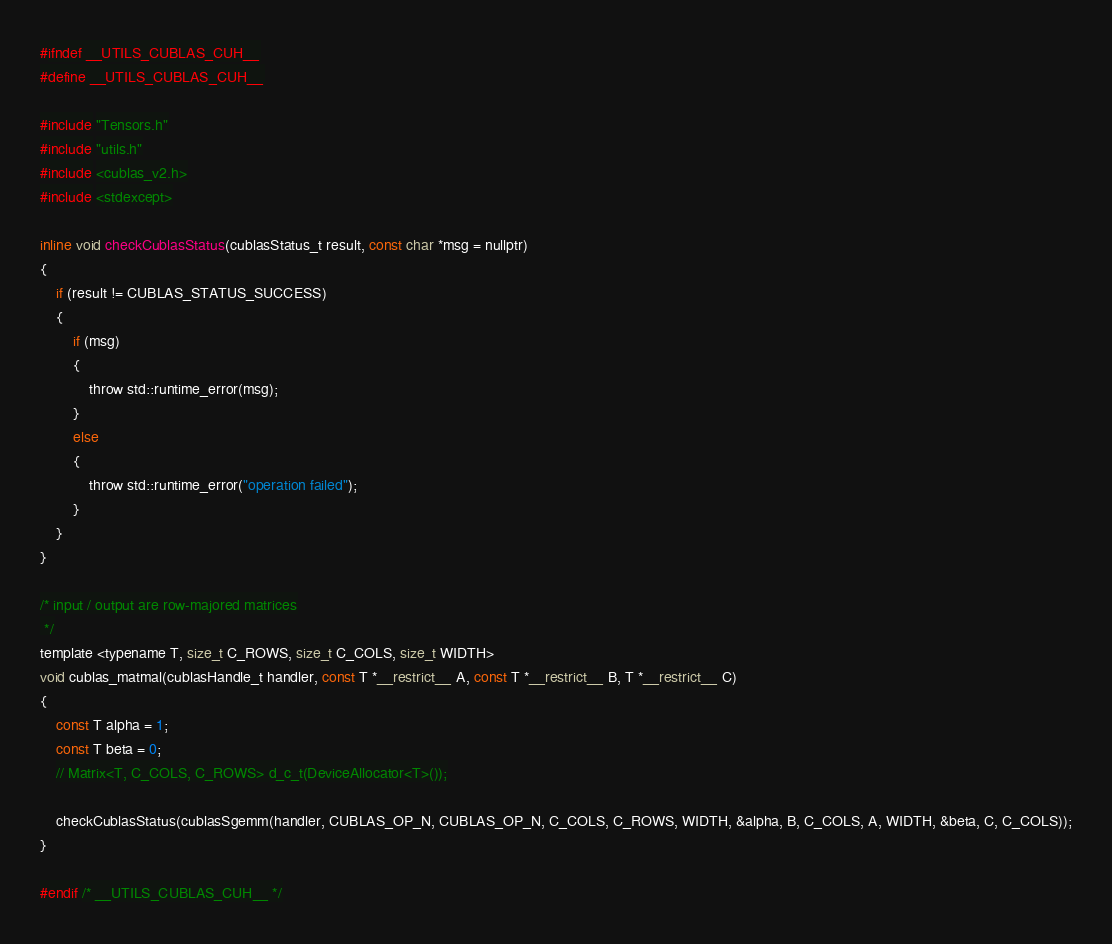<code> <loc_0><loc_0><loc_500><loc_500><_Cuda_>#ifndef __UTILS_CUBLAS_CUH__
#define __UTILS_CUBLAS_CUH__

#include "Tensors.h"
#include "utils.h"
#include <cublas_v2.h>
#include <stdexcept>

inline void checkCublasStatus(cublasStatus_t result, const char *msg = nullptr)
{
    if (result != CUBLAS_STATUS_SUCCESS)
    {
        if (msg)
        {
            throw std::runtime_error(msg);
        }
        else
        {
            throw std::runtime_error("operation failed");
        }
    }
}

/* input / output are row-majored matrices
 */
template <typename T, size_t C_ROWS, size_t C_COLS, size_t WIDTH>
void cublas_matmal(cublasHandle_t handler, const T *__restrict__ A, const T *__restrict__ B, T *__restrict__ C)
{
    const T alpha = 1;
    const T beta = 0;
    // Matrix<T, C_COLS, C_ROWS> d_c_t(DeviceAllocator<T>());

    checkCublasStatus(cublasSgemm(handler, CUBLAS_OP_N, CUBLAS_OP_N, C_COLS, C_ROWS, WIDTH, &alpha, B, C_COLS, A, WIDTH, &beta, C, C_COLS));
}

#endif /* __UTILS_CUBLAS_CUH__ */
</code> 